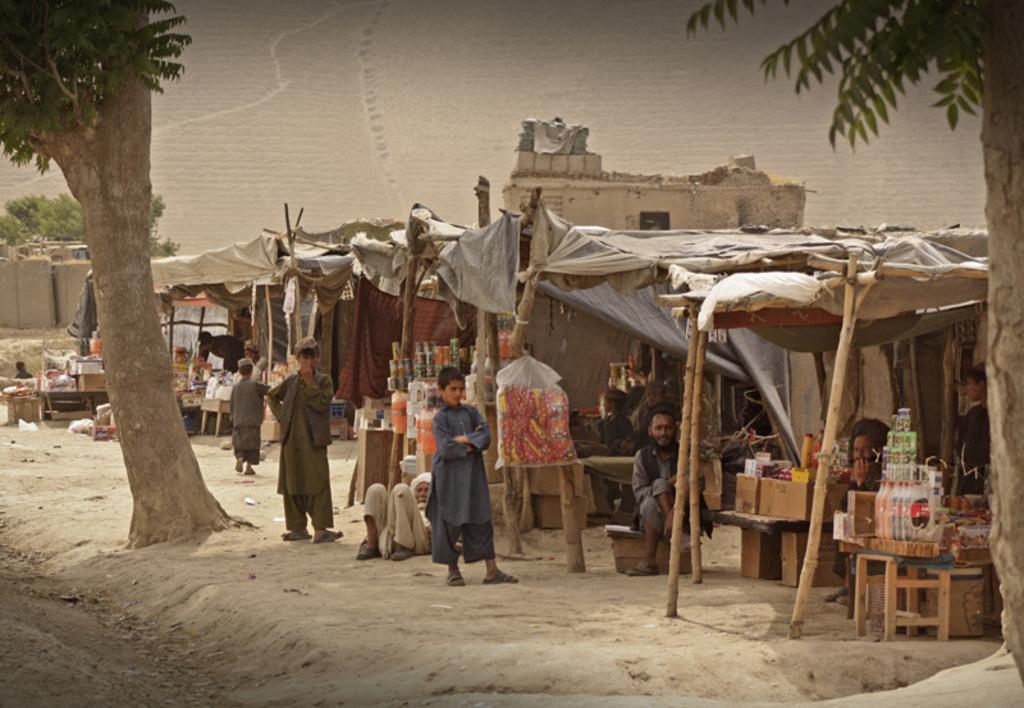Could you give a brief overview of what you see in this image? At the bottom of the picture, we see the sand. in this picture, we see two boys are standing. Beside them, we see people are sitting under the tents. We see the tables on which packets, boxes and cool drink bottles and some other objects are placed under the tent. We even see the carton boxes are placed on the table. These might be the stalls. On the right side, we see a tree. On the left side, we see a tree. There are trees and buildings in the background. At the top, we see the sky. 